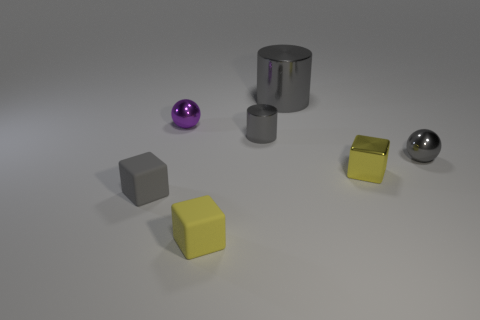Add 1 big cylinders. How many objects exist? 8 Subtract all cylinders. How many objects are left? 5 Subtract all rubber objects. Subtract all metal cubes. How many objects are left? 4 Add 5 big shiny things. How many big shiny things are left? 6 Add 2 tiny metallic balls. How many tiny metallic balls exist? 4 Subtract 0 red blocks. How many objects are left? 7 